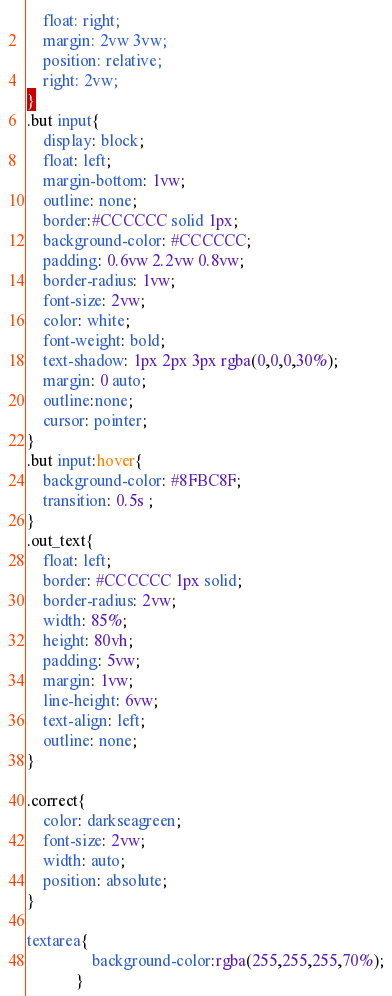<code> <loc_0><loc_0><loc_500><loc_500><_CSS_>	float: right;
	margin: 2vw 3vw;
	position: relative;
	right: 2vw;
}
.but input{
	display: block;
	float: left;
	margin-bottom: 1vw;
	outline: none;
	border:#CCCCCC solid 1px;
	background-color: #CCCCCC;
	padding: 0.6vw 2.2vw 0.8vw;
	border-radius: 1vw;
	font-size: 2vw;
	color: white;
	font-weight: bold;
	text-shadow: 1px 2px 3px rgba(0,0,0,30%);
	margin: 0 auto;
	outline:none;
	cursor: pointer;
}
.but input:hover{
	background-color: #8FBC8F;
	transition: 0.5s ;
}
.out_text{
	float: left;
	border: #CCCCCC 1px solid;
	border-radius: 2vw;
	width: 85%;
	height: 80vh;
	padding: 5vw;
	margin: 1vw;
	line-height: 6vw;
	text-align: left;
	outline: none;
}

.correct{
	color: darkseagreen;
	font-size: 2vw;
	width: auto;
	position: absolute;
}

textarea{
				background-color:rgba(255,255,255,70%);
			}</code> 